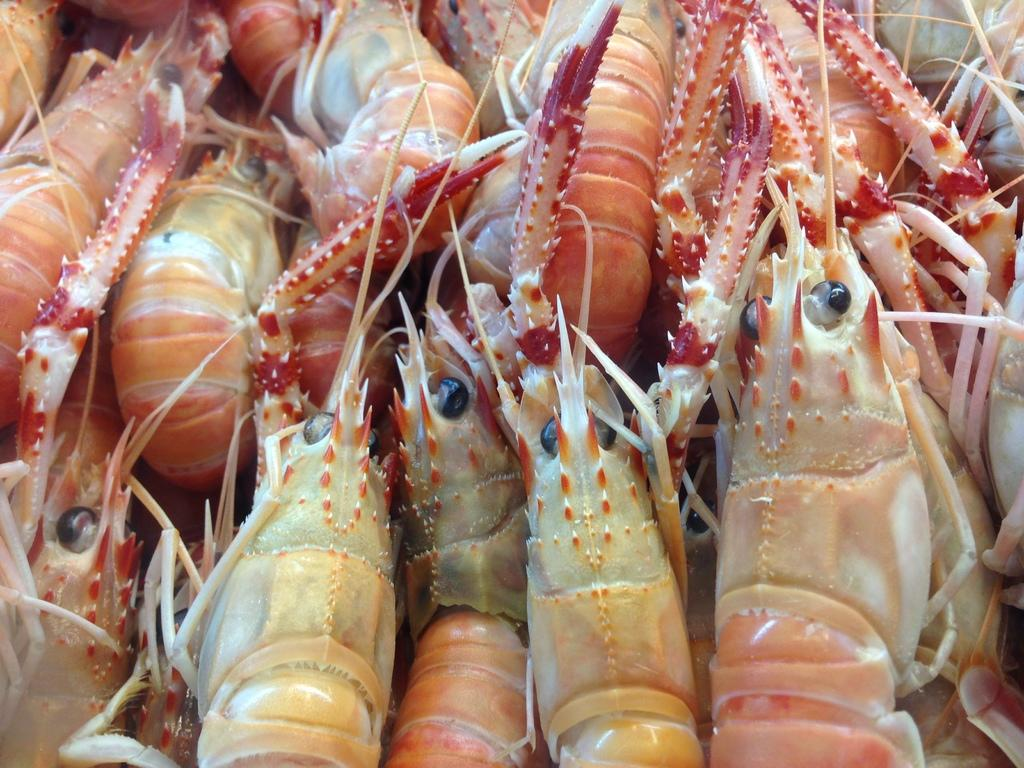What type of seafood is visible in the image? There are prawns in the image. How many divisions of earth can be seen in the image? There is no division of earth present in the image; it features prawns. What type of activity are the boys engaged in within the image? There is no reference to boys or any activity in the image, as it only features prawns. 